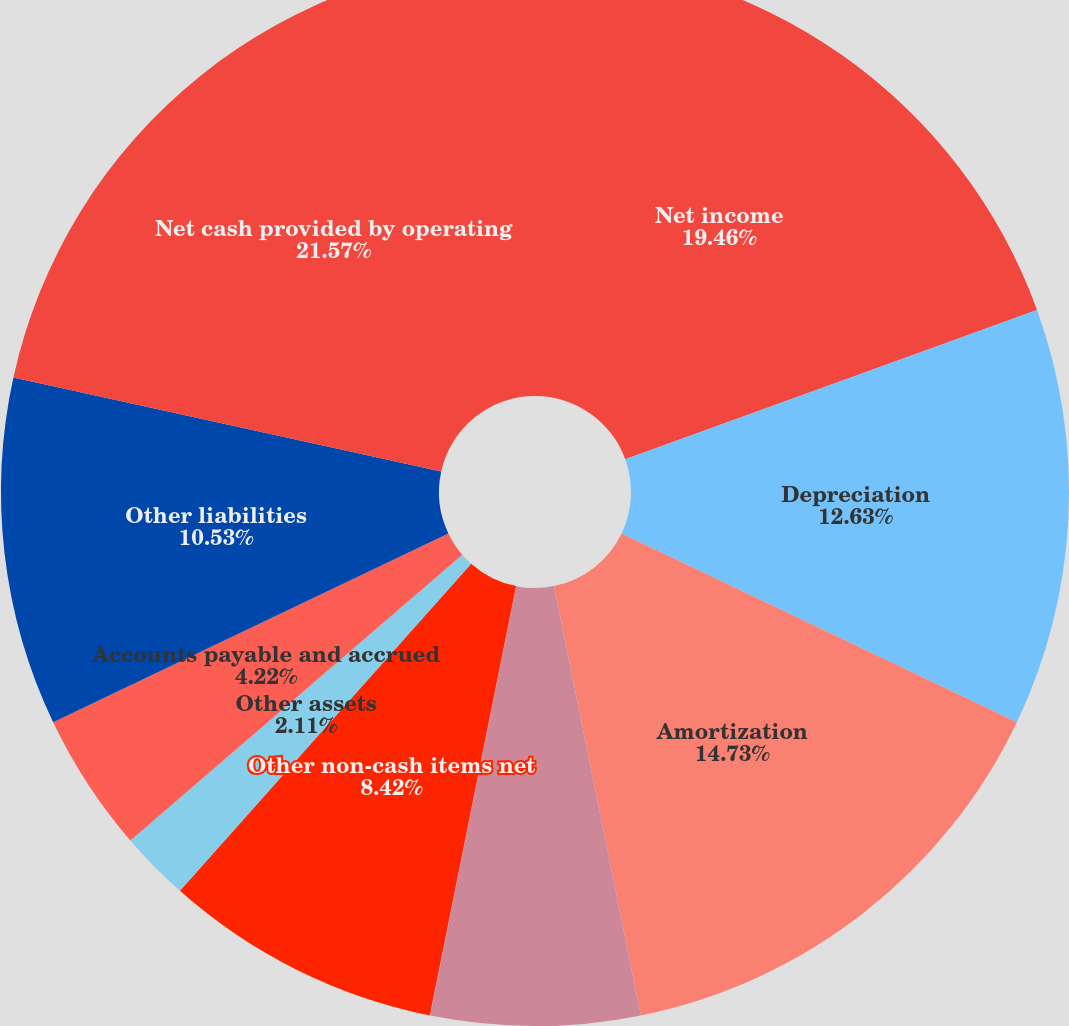Convert chart. <chart><loc_0><loc_0><loc_500><loc_500><pie_chart><fcel>Net income<fcel>Depreciation<fcel>Amortization<fcel>Deferred income tax provision<fcel>Realized (gain)/loss on<fcel>Other non-cash items net<fcel>Other assets<fcel>Accounts payable and accrued<fcel>Other liabilities<fcel>Net cash provided by operating<nl><fcel>19.46%<fcel>12.63%<fcel>14.73%<fcel>6.32%<fcel>0.01%<fcel>8.42%<fcel>2.11%<fcel>4.22%<fcel>10.53%<fcel>21.56%<nl></chart> 